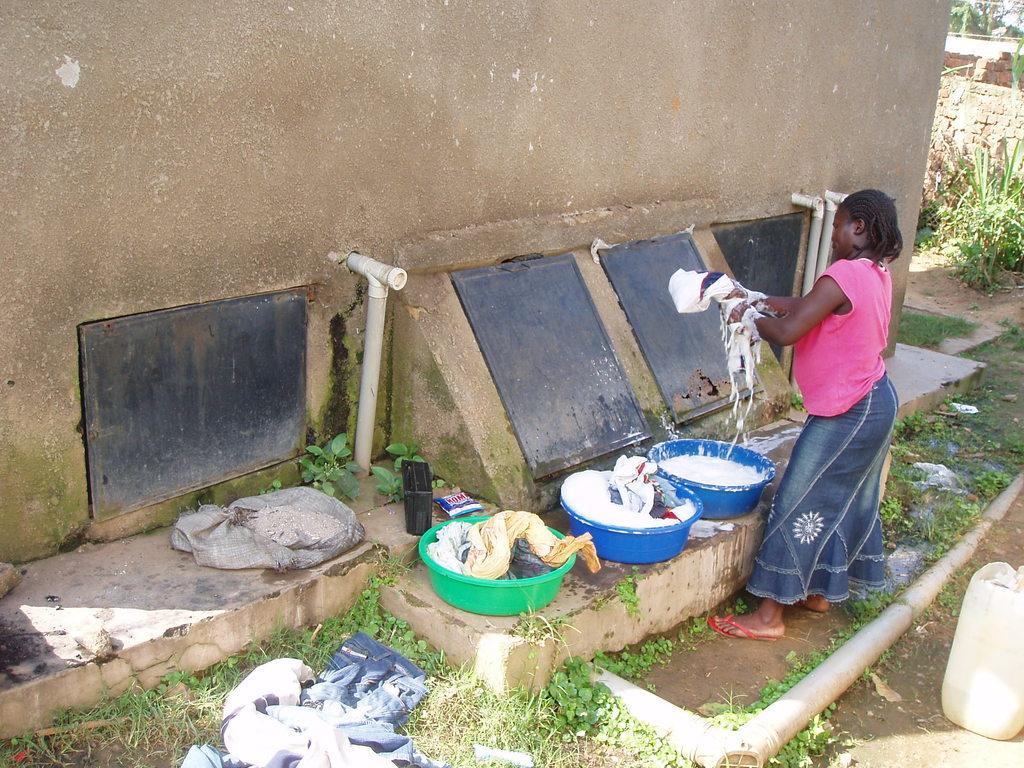Could you give a brief overview of what you see in this image? This picture is taken outside, where there is a woman in pink and blue colored dress, washing clothes and in front of here there are three tubs with clothes in it and on the right bottom of the picture there are pipes, a water container and on bottom we see few clothes. On top we see the wall. 